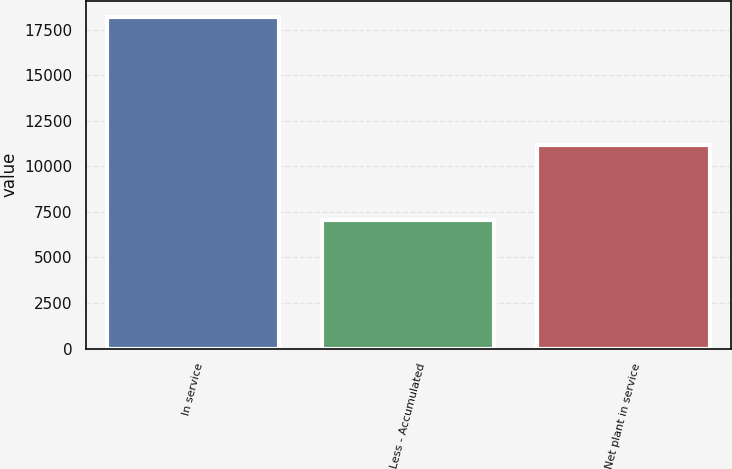Convert chart. <chart><loc_0><loc_0><loc_500><loc_500><bar_chart><fcel>In service<fcel>Less - Accumulated<fcel>Net plant in service<nl><fcel>18172<fcel>7028<fcel>11144<nl></chart> 